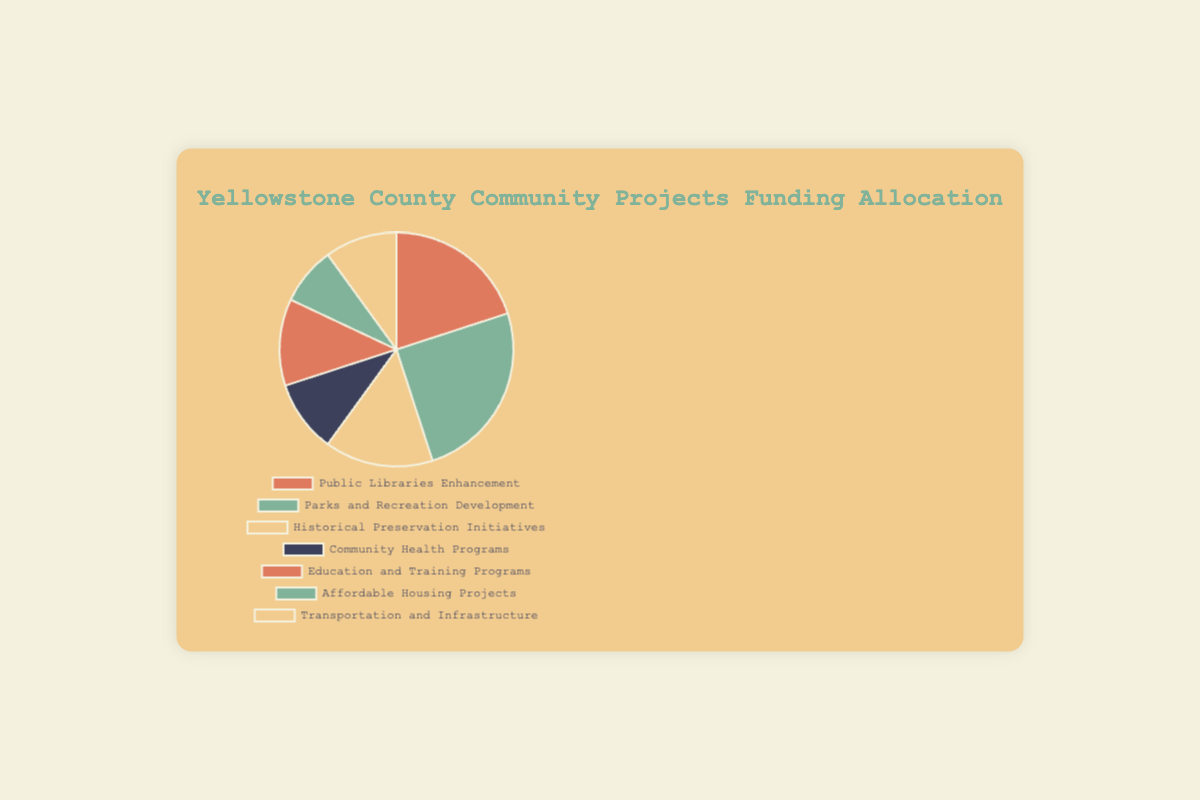What percentage of the total funding is allocated to Parks and Recreation Development? The segment representing Parks and Recreation Development covers 25% of the pie chart.
Answer: 25% Which project received the smallest percentage of funding? By examining the pie chart, the smallest segment corresponds to Affordable Housing Projects, which has 8% of the funding.
Answer: Affordable Housing Projects What is the combined percentage of funding for Community Health Programs and Transportation and Infrastructure? The pie chart shows Community Health Programs at 10% and Transportation and Infrastructure also at 10%. Adding these together results in 10% + 10% = 20%.
Answer: 20% Which two projects, when combined, have a funding allocation equal to that of Parks and Recreation Development? The pie chart indicates that Parks and Recreation Development is allocated 25%. Summing the allocations for Education and Training Programs (12%) and Affordable Housing Projects (8%) yields 12% + 8% = 20%, which is still insufficient. However, adding Community Health Programs (10%) and Transportation and Infrastructure (10%) gives 10% + 10% = 20%. Thus, no combination of two specific projects precisely matches the 25% funding of Parks and Recreation Development.
Answer: None How does the percentage allocation for Historical Preservation Initiatives compare to that for Community Health Programs? The pie chart shows Historical Preservation Initiatives have 15% and Community Health Programs have 10%. Thus, the percentage for Historical Preservation Initiatives is greater.
Answer: Historical Preservation Initiatives have a higher percentage than Community Health Programs What is the total percentage of funding allocated to Public Libraries Enhancement, Parks and Recreation Development, and Historical Preservation Initiatives? The chart segments indicate that Public Libraries Enhancement has 20%, Parks and Recreation Development has 25%, and Historical Preservation Initiatives has 15%. Adding them together gives 20% + 25% + 15% = 60%.
Answer: 60% Among all the projects, which one received nearly double the percentage of Transportation and Infrastructure? Transportation and Infrastructure is allocated 10%. The nearest project with double this percentage is Parks and Recreation Development, which has 25%. Although not exactly double, it is the closest.
Answer: Parks and Recreation Development Which project has the same percentage allocation as Transportation and Infrastructure? By examining the pie chart, the Community Health Programs segment also indicates 10%, which matches the allocation for Transportation and Infrastructure.
Answer: Community Health Programs 